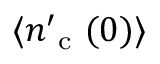Convert formula to latex. <formula><loc_0><loc_0><loc_500><loc_500>\langle n _ { c } ^ { \prime } ( 0 ) \rangle</formula> 